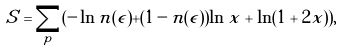Convert formula to latex. <formula><loc_0><loc_0><loc_500><loc_500>S = \sum _ { p } ( - \ln n ( \epsilon ) + ( 1 - n ( \epsilon ) ) \ln x + \ln ( 1 + 2 x ) ) ,</formula> 